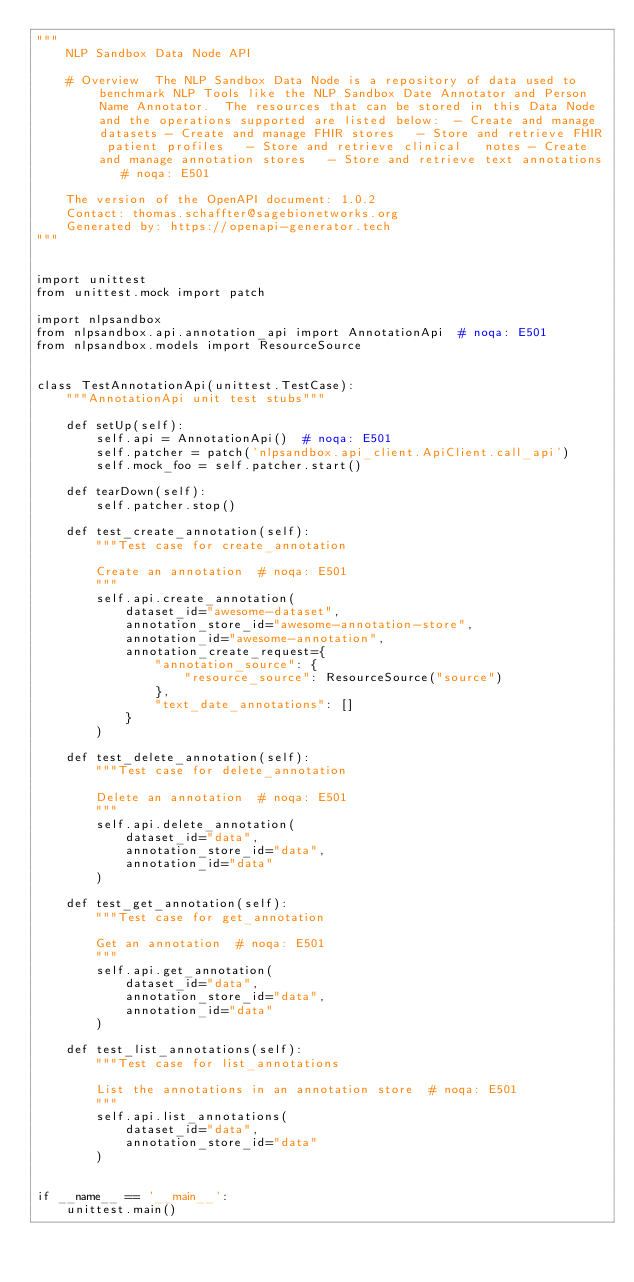Convert code to text. <code><loc_0><loc_0><loc_500><loc_500><_Python_>"""
    NLP Sandbox Data Node API

    # Overview  The NLP Sandbox Data Node is a repository of data used to benchmark NLP Tools like the NLP Sandbox Date Annotator and Person Name Annotator.  The resources that can be stored in this Data Node and the operations supported are listed below:  - Create and manage datasets - Create and manage FHIR stores   - Store and retrieve FHIR patient profiles   - Store and retrieve clinical   notes - Create and manage annotation stores   - Store and retrieve text annotations   # noqa: E501

    The version of the OpenAPI document: 1.0.2
    Contact: thomas.schaffter@sagebionetworks.org
    Generated by: https://openapi-generator.tech
"""


import unittest
from unittest.mock import patch

import nlpsandbox
from nlpsandbox.api.annotation_api import AnnotationApi  # noqa: E501
from nlpsandbox.models import ResourceSource


class TestAnnotationApi(unittest.TestCase):
    """AnnotationApi unit test stubs"""

    def setUp(self):
        self.api = AnnotationApi()  # noqa: E501
        self.patcher = patch('nlpsandbox.api_client.ApiClient.call_api')
        self.mock_foo = self.patcher.start()

    def tearDown(self):
        self.patcher.stop()

    def test_create_annotation(self):
        """Test case for create_annotation

        Create an annotation  # noqa: E501
        """
        self.api.create_annotation(
            dataset_id="awesome-dataset",
            annotation_store_id="awesome-annotation-store",
            annotation_id="awesome-annotation",
            annotation_create_request={
                "annotation_source": {
                    "resource_source": ResourceSource("source")
                },
                "text_date_annotations": []
            }
        )

    def test_delete_annotation(self):
        """Test case for delete_annotation

        Delete an annotation  # noqa: E501
        """
        self.api.delete_annotation(
            dataset_id="data",
            annotation_store_id="data",
            annotation_id="data"
        )

    def test_get_annotation(self):
        """Test case for get_annotation

        Get an annotation  # noqa: E501
        """
        self.api.get_annotation(
            dataset_id="data",
            annotation_store_id="data",
            annotation_id="data"
        )

    def test_list_annotations(self):
        """Test case for list_annotations

        List the annotations in an annotation store  # noqa: E501
        """
        self.api.list_annotations(
            dataset_id="data",
            annotation_store_id="data"
        )


if __name__ == '__main__':
    unittest.main()
</code> 